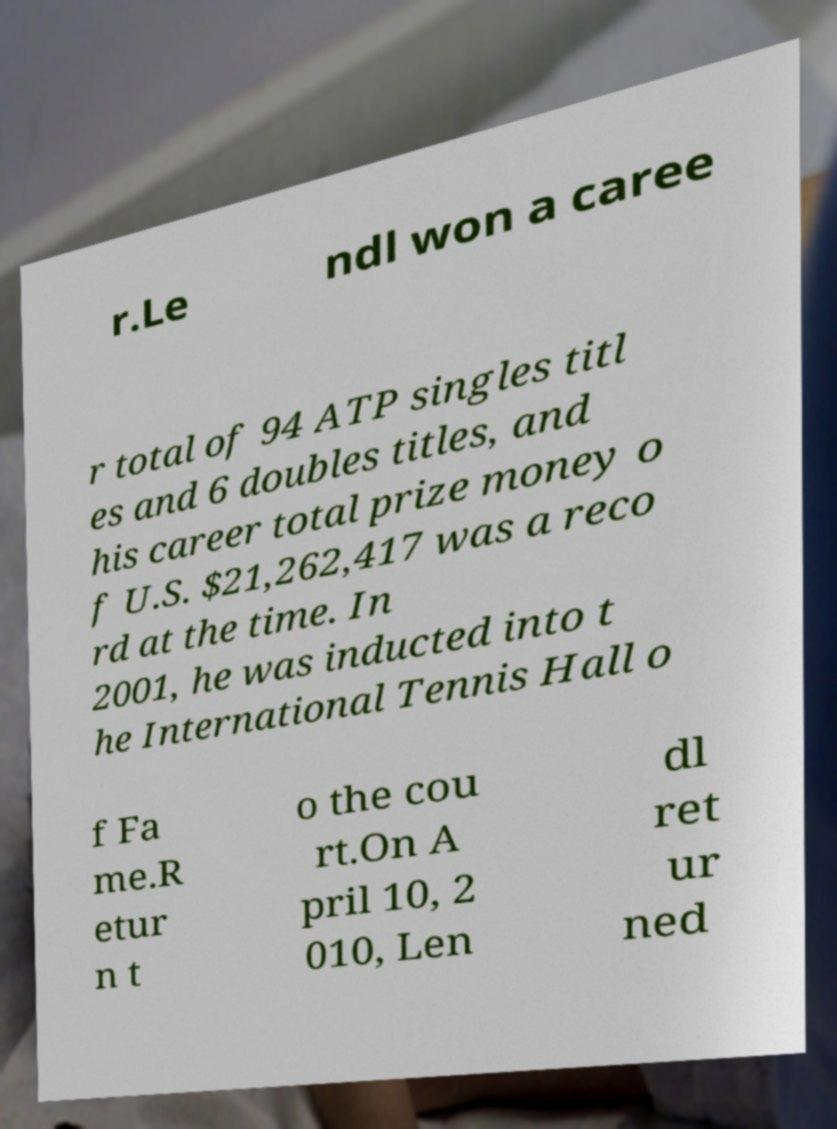Please identify and transcribe the text found in this image. r.Le ndl won a caree r total of 94 ATP singles titl es and 6 doubles titles, and his career total prize money o f U.S. $21,262,417 was a reco rd at the time. In 2001, he was inducted into t he International Tennis Hall o f Fa me.R etur n t o the cou rt.On A pril 10, 2 010, Len dl ret ur ned 